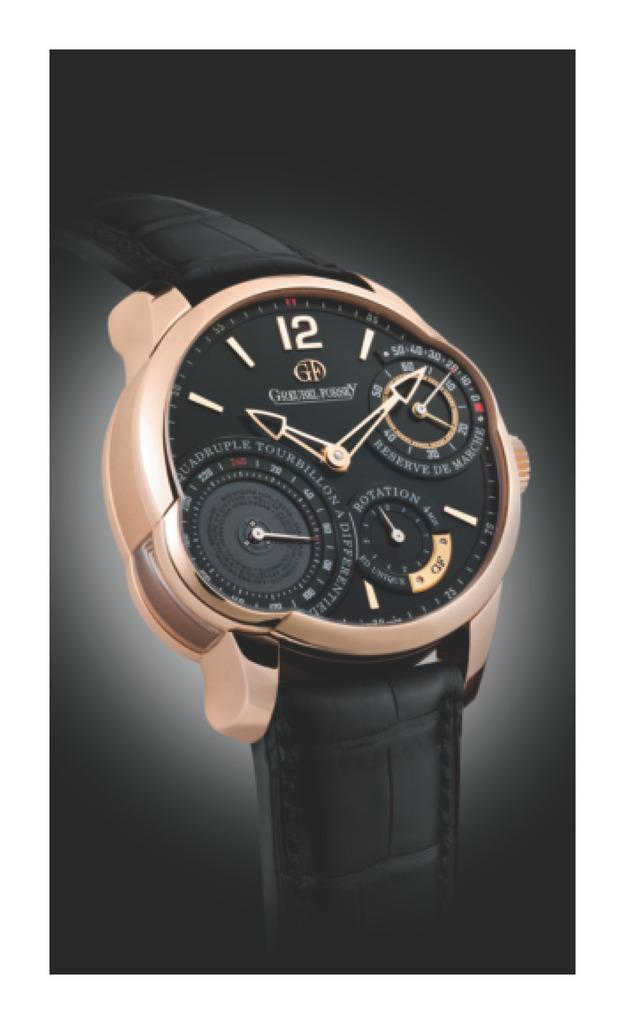<image>
Summarize the visual content of the image. A black leather banded wristwatch with a gold rimmed face and 3 extra timing circles on the main face. 